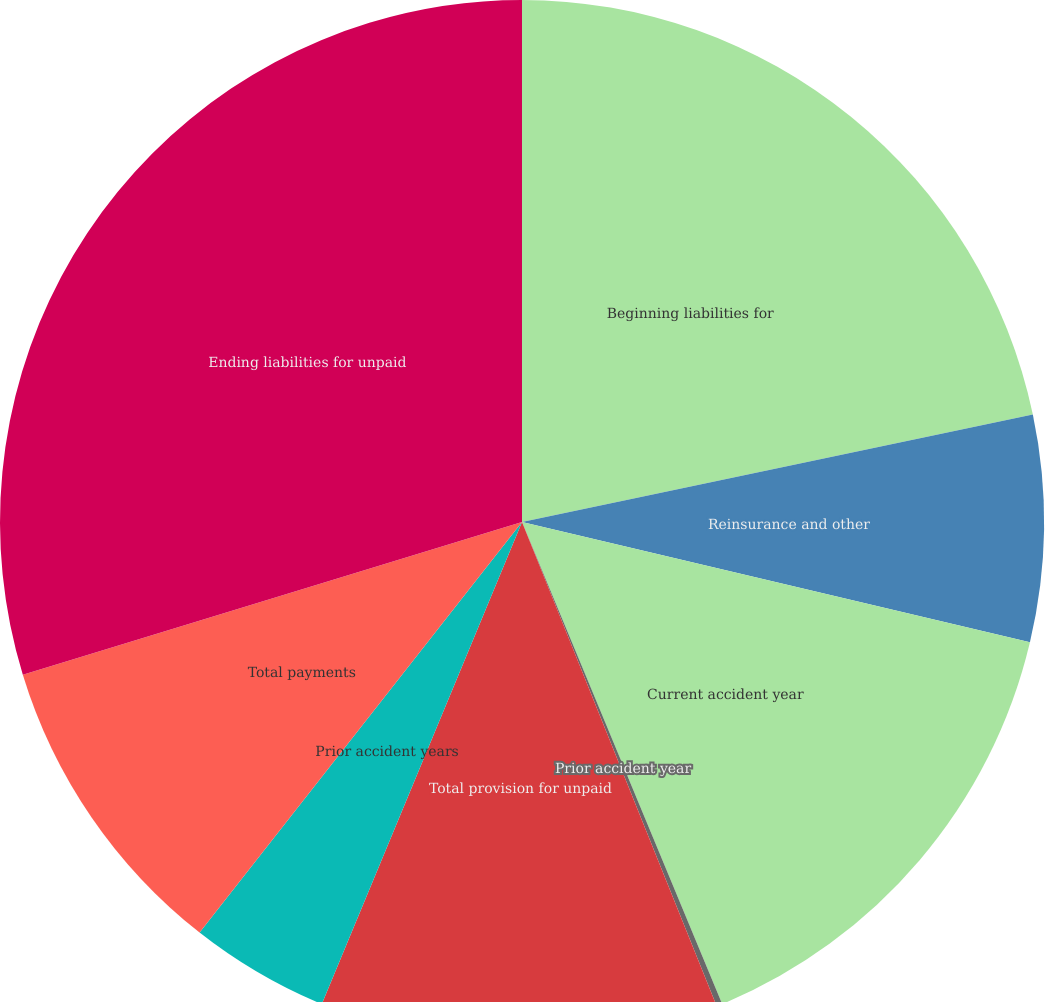Convert chart. <chart><loc_0><loc_0><loc_500><loc_500><pie_chart><fcel>Beginning liabilities for<fcel>Reinsurance and other<fcel>Current accident year<fcel>Prior accident year<fcel>Total provision for unpaid<fcel>Prior accident years<fcel>Total payments<fcel>Ending liabilities for unpaid<nl><fcel>21.7%<fcel>7.0%<fcel>15.03%<fcel>0.18%<fcel>12.35%<fcel>4.33%<fcel>9.68%<fcel>29.72%<nl></chart> 